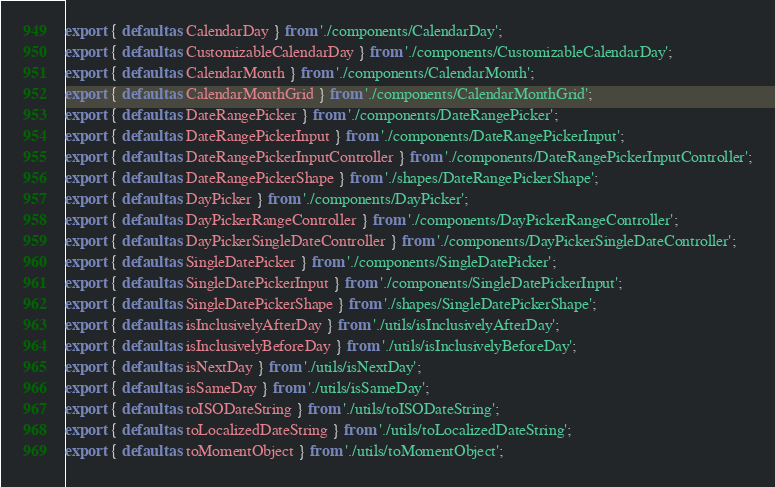<code> <loc_0><loc_0><loc_500><loc_500><_JavaScript_>export { default as CalendarDay } from './components/CalendarDay';
export { default as CustomizableCalendarDay } from './components/CustomizableCalendarDay';
export { default as CalendarMonth } from './components/CalendarMonth';
export { default as CalendarMonthGrid } from './components/CalendarMonthGrid';
export { default as DateRangePicker } from './components/DateRangePicker';
export { default as DateRangePickerInput } from './components/DateRangePickerInput';
export { default as DateRangePickerInputController } from './components/DateRangePickerInputController';
export { default as DateRangePickerShape } from './shapes/DateRangePickerShape';
export { default as DayPicker } from './components/DayPicker';
export { default as DayPickerRangeController } from './components/DayPickerRangeController';
export { default as DayPickerSingleDateController } from './components/DayPickerSingleDateController';
export { default as SingleDatePicker } from './components/SingleDatePicker';
export { default as SingleDatePickerInput } from './components/SingleDatePickerInput';
export { default as SingleDatePickerShape } from './shapes/SingleDatePickerShape';
export { default as isInclusivelyAfterDay } from './utils/isInclusivelyAfterDay';
export { default as isInclusivelyBeforeDay } from './utils/isInclusivelyBeforeDay';
export { default as isNextDay } from './utils/isNextDay';
export { default as isSameDay } from './utils/isSameDay';
export { default as toISODateString } from './utils/toISODateString';
export { default as toLocalizedDateString } from './utils/toLocalizedDateString';
export { default as toMomentObject } from './utils/toMomentObject';
</code> 